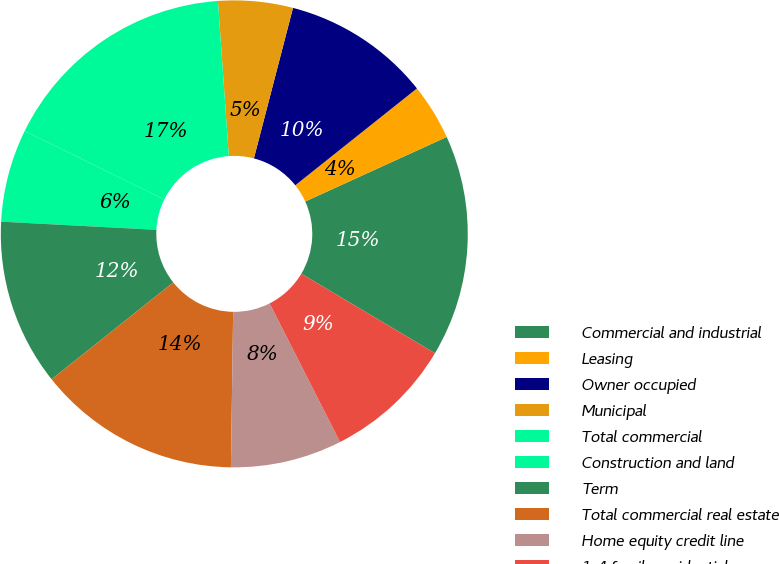Convert chart to OTSL. <chart><loc_0><loc_0><loc_500><loc_500><pie_chart><fcel>Commercial and industrial<fcel>Leasing<fcel>Owner occupied<fcel>Municipal<fcel>Total commercial<fcel>Construction and land<fcel>Term<fcel>Total commercial real estate<fcel>Home equity credit line<fcel>1-4 family residential<nl><fcel>15.35%<fcel>3.89%<fcel>10.25%<fcel>5.16%<fcel>16.62%<fcel>6.43%<fcel>11.53%<fcel>14.07%<fcel>7.71%<fcel>8.98%<nl></chart> 